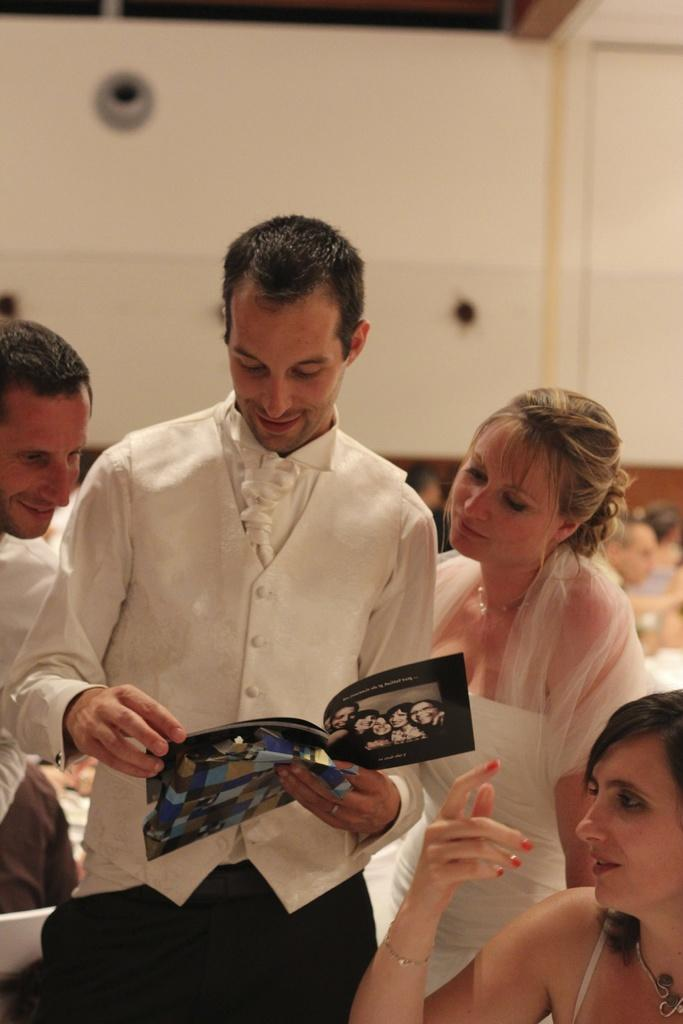How many people are in the image? There are persons in the image, but the exact number is not specified. What is one person doing in the image? One person is holding a book in his hand. What positions are some of the persons in? Some persons are sitting. What color is the background of the image? The background of the image is cream-colored. How many cups of coffee are on the table in the image? There is no mention of cups or a table in the image, so it is not possible to answer this question. 